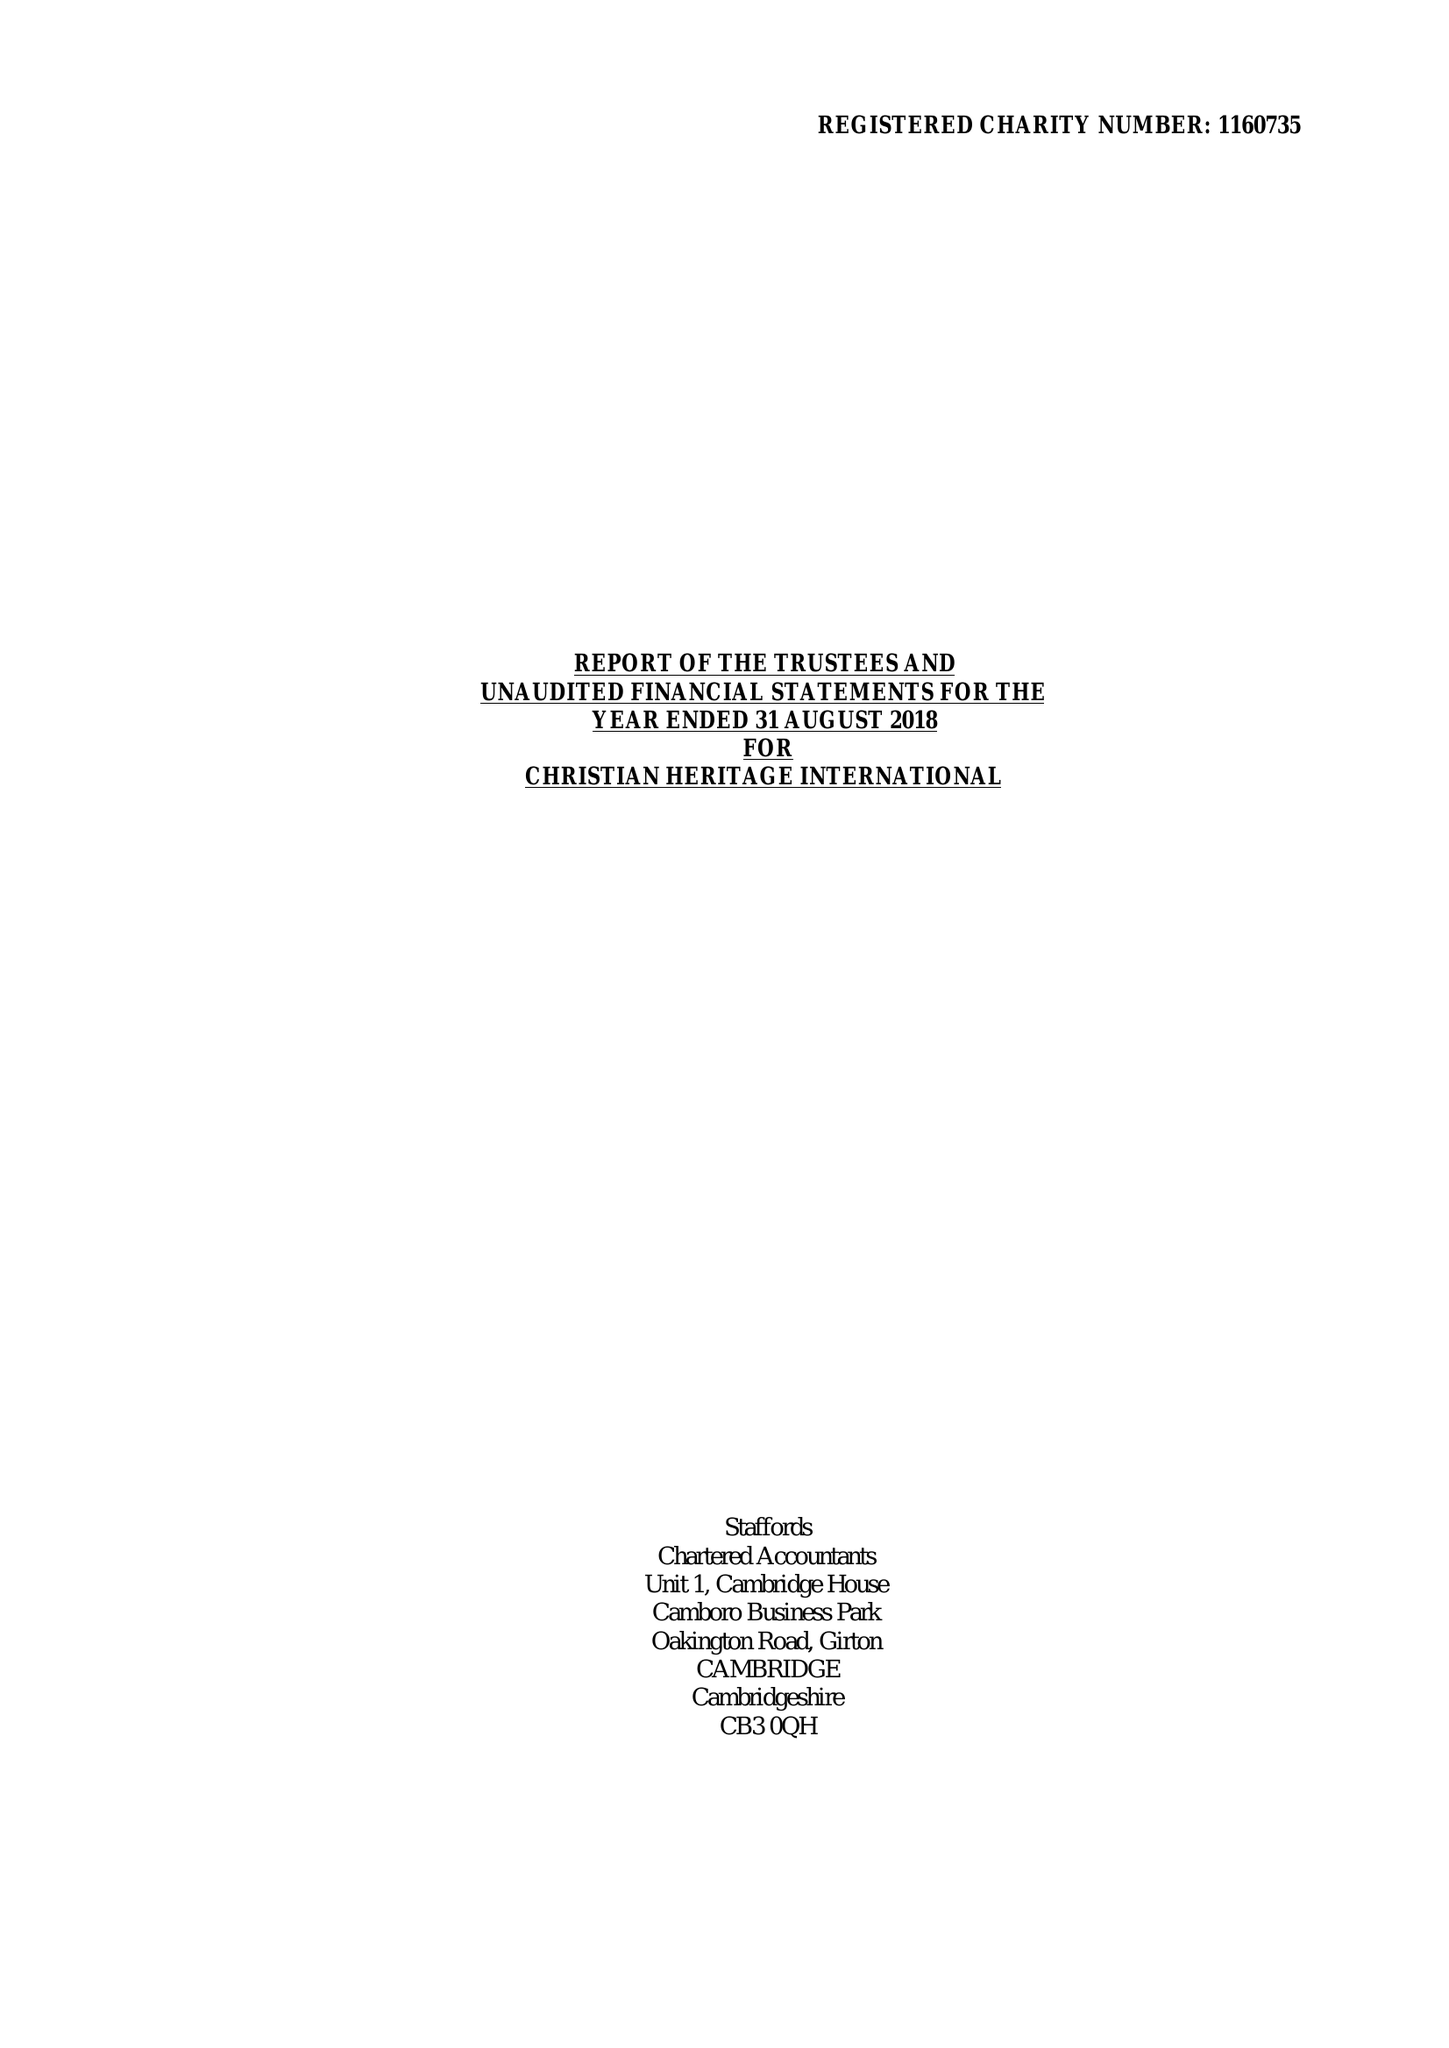What is the value for the spending_annually_in_british_pounds?
Answer the question using a single word or phrase. None 